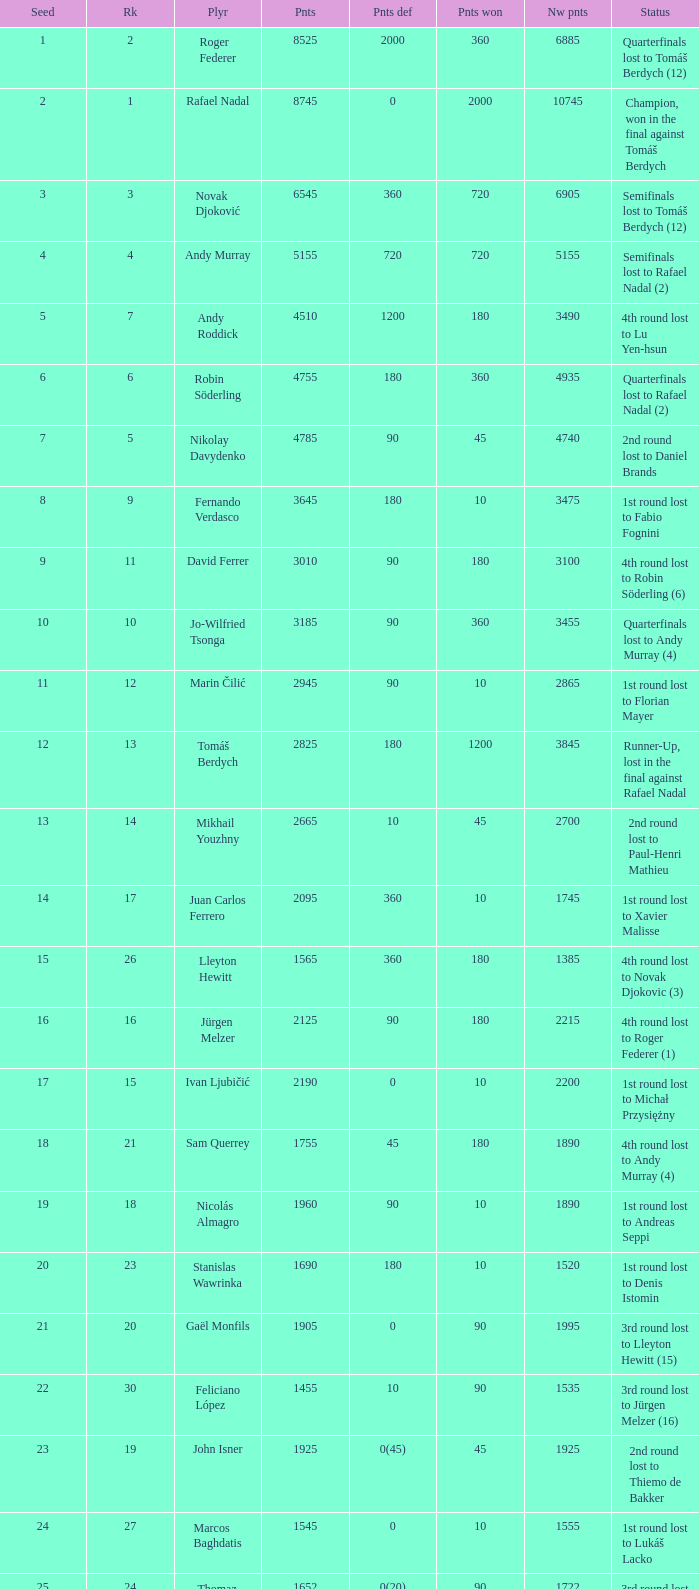Name the status for points 3185 Quarterfinals lost to Andy Murray (4). 